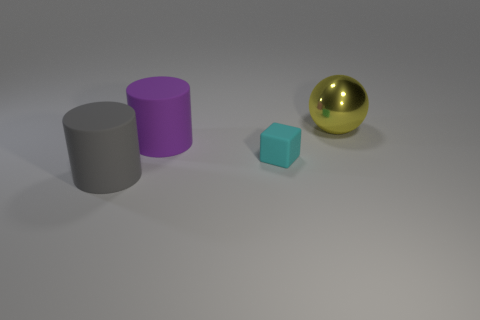Add 3 small yellow matte cubes. How many objects exist? 7 Subtract 1 cubes. How many cubes are left? 0 Subtract all balls. How many objects are left? 3 Subtract 0 red cylinders. How many objects are left? 4 Subtract all purple cylinders. Subtract all brown spheres. How many cylinders are left? 1 Subtract all cyan cubes. Subtract all purple rubber objects. How many objects are left? 2 Add 3 big purple things. How many big purple things are left? 4 Add 1 big cyan things. How many big cyan things exist? 1 